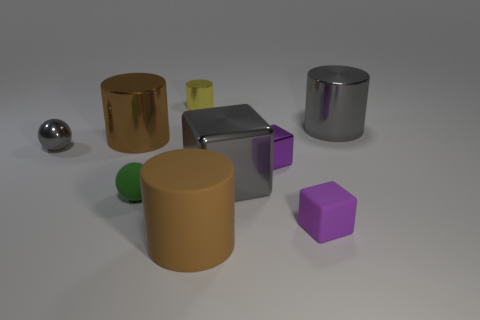What can you infer about the surface the objects are on? The objects are resting on a flat, matte surface that diffusely reflects light. The shadows indicate the surface is even and smooth. 